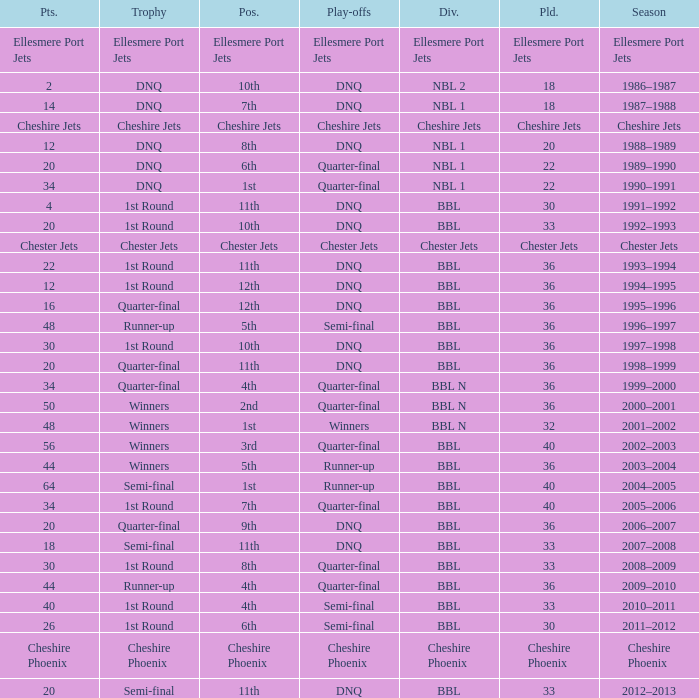During the play-off quarter-final which team scored position was the team that scored 56 points? 3rd. 